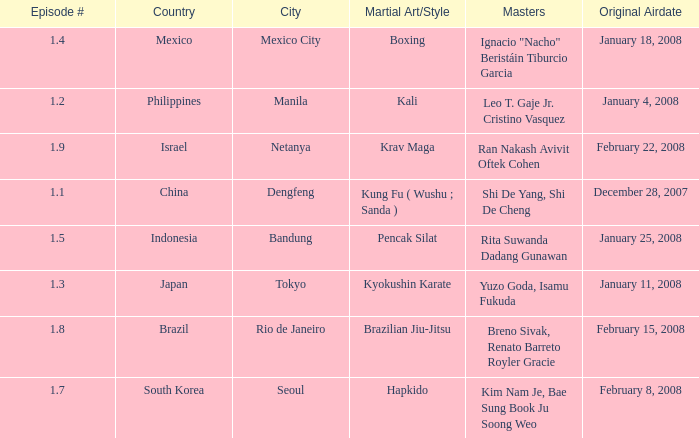How many times did episode 1.8 air? 1.0. 